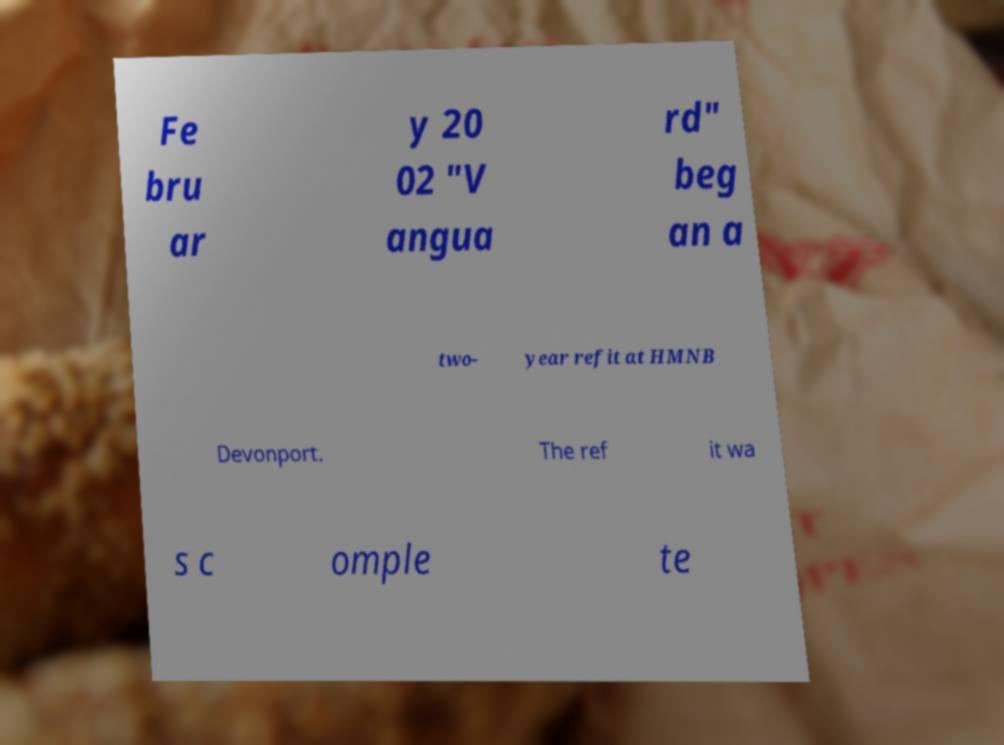Can you read and provide the text displayed in the image?This photo seems to have some interesting text. Can you extract and type it out for me? Fe bru ar y 20 02 "V angua rd" beg an a two- year refit at HMNB Devonport. The ref it wa s c omple te 